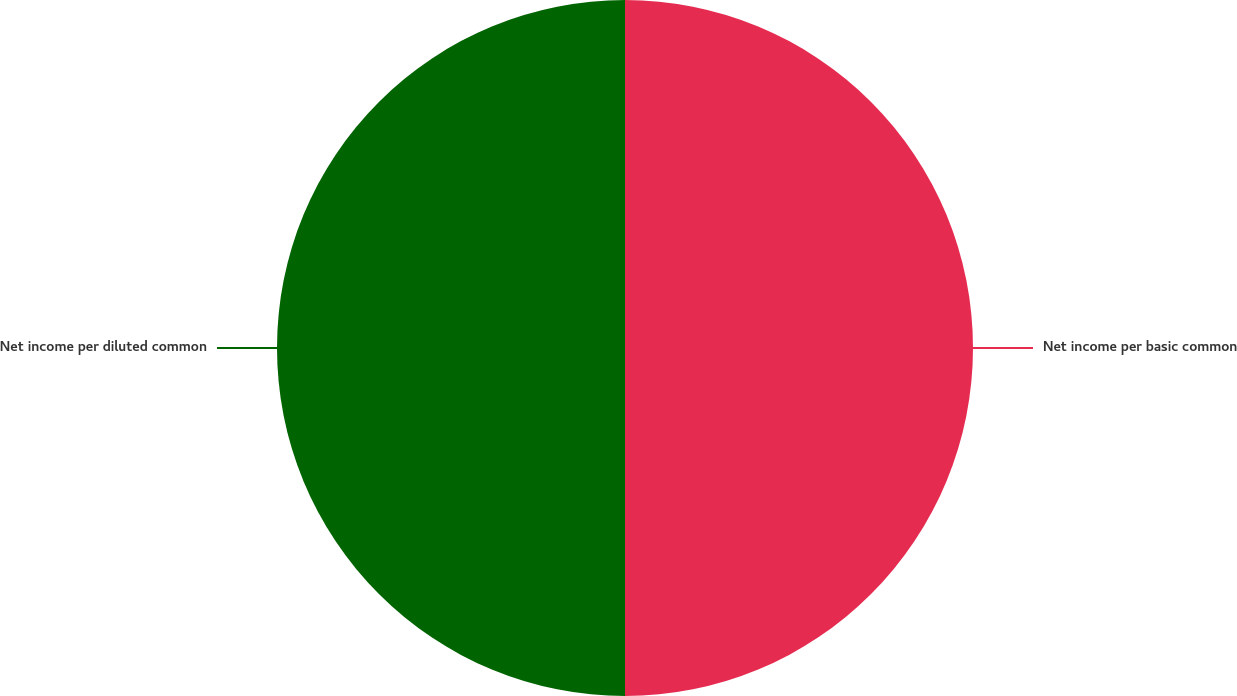Convert chart to OTSL. <chart><loc_0><loc_0><loc_500><loc_500><pie_chart><fcel>Net income per basic common<fcel>Net income per diluted common<nl><fcel>50.0%<fcel>50.0%<nl></chart> 